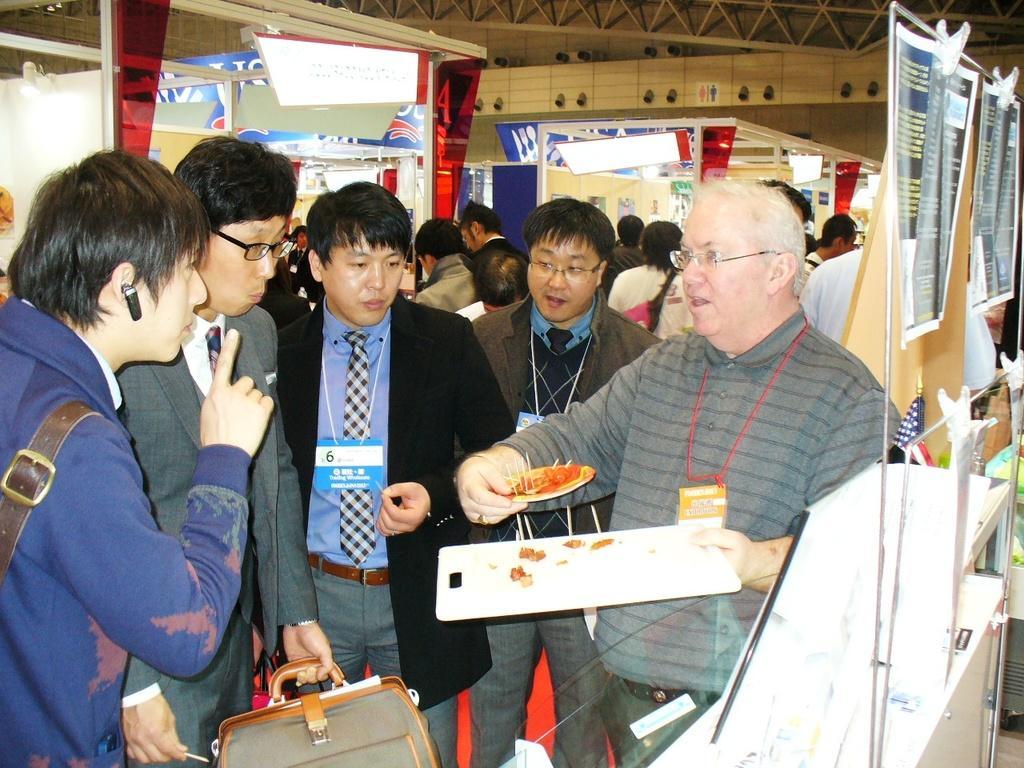How would you summarize this image in a sentence or two? In the picture I can see a person wearing grey color T-shirt, identity card and spectacles is holding the tray and some plate in his hands and he is on the right side of the image. Here I can see a few more people standing, here I can see posts are hanged to the stand using poles, I can see people walking on the floor,I can see boards, banners, stalls and lights in the background. 